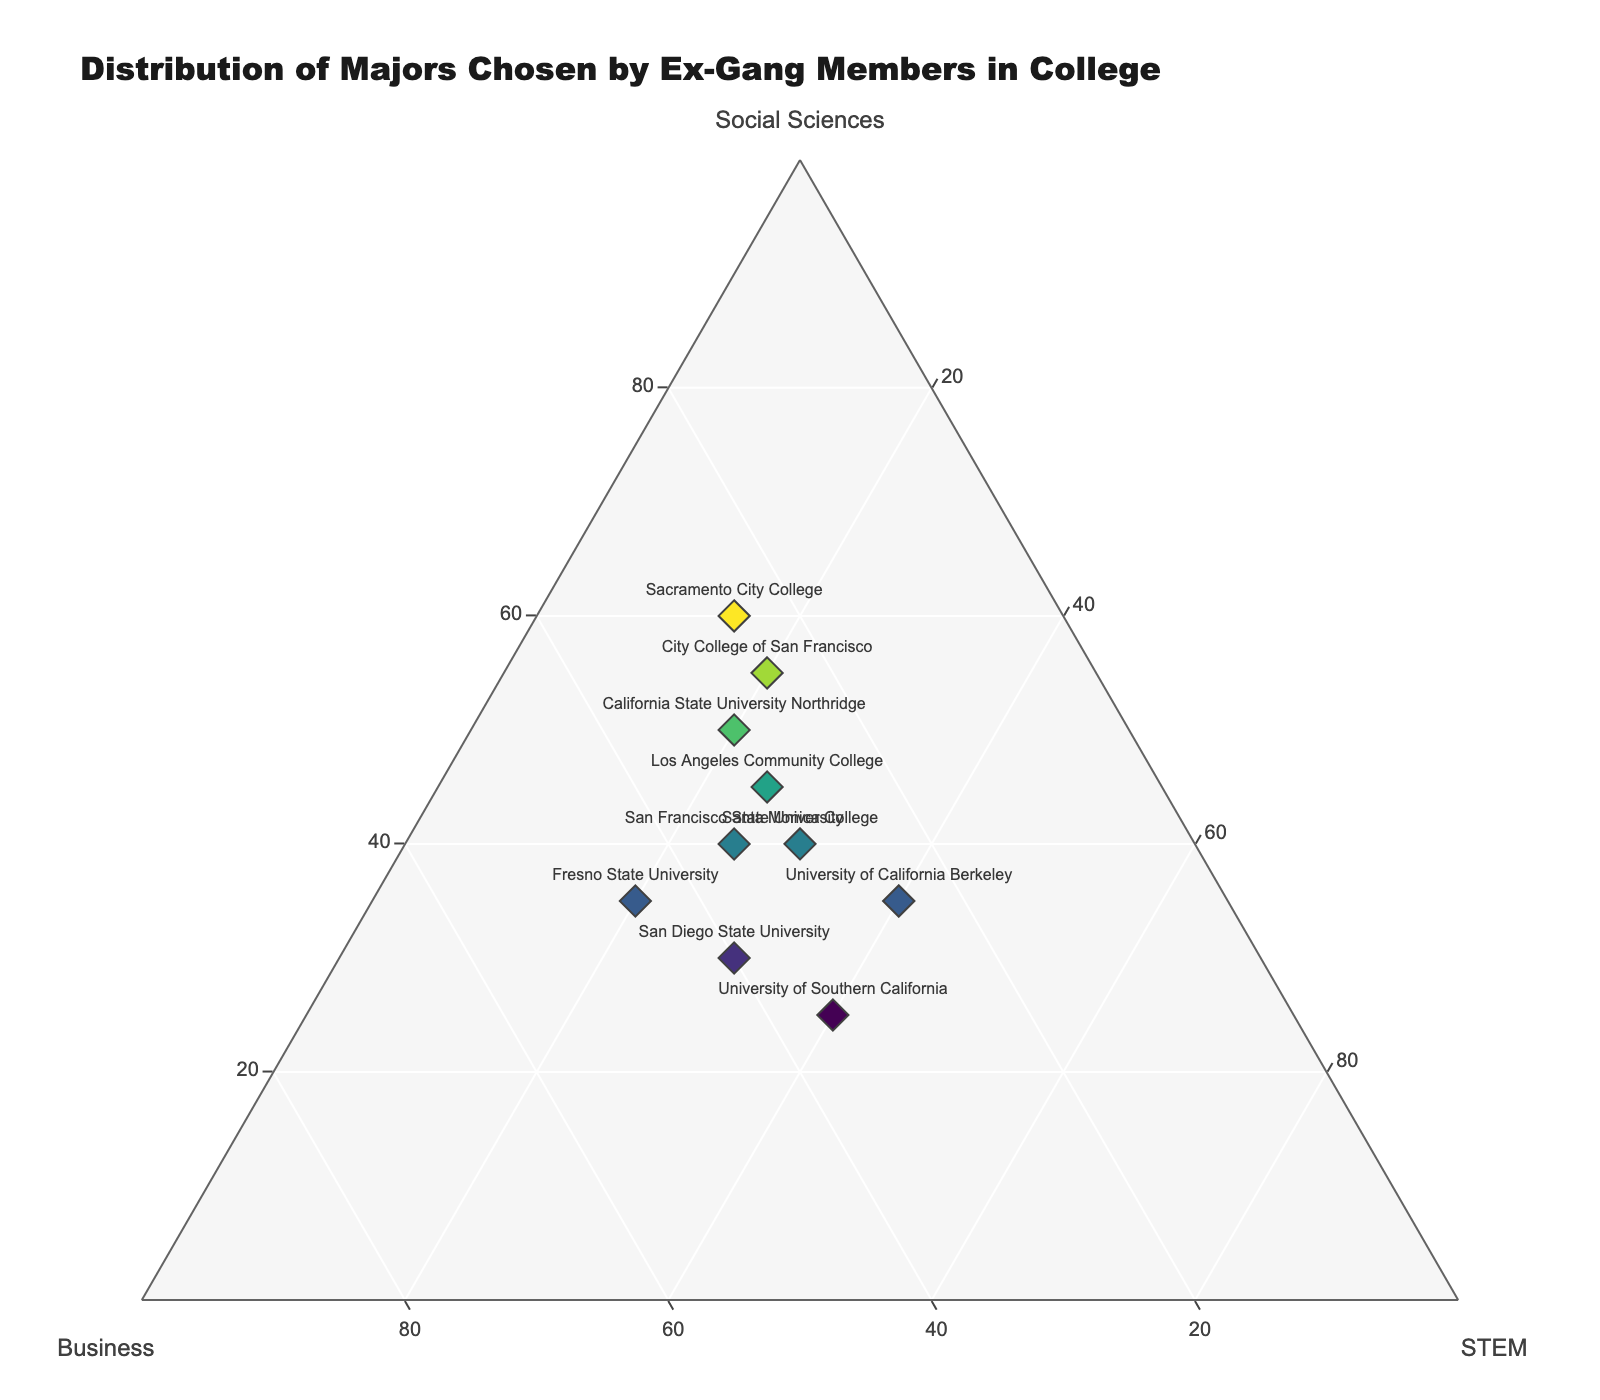What is the title of the plot? The title is usually displayed at the top of the figure. In this case, the title of the plot provides a summary of what the figure represents.
Answer: Distribution of Majors Chosen by Ex-Gang Members in College How many educational institutions are represented in the plot? Count the number of unique data points or markers, each representing an educational institution.
Answer: 10 Which institution has the highest percentage of students in Social Sciences? Look for the marker placed furthest along the 'Social Sciences' axis. The text label next to this marker will indicate the institution.
Answer: Sacramento City College (60%) Which institution has an equal distribution of majors between Social Sciences, Business, and STEM? Look for a marker placed centrally where all three categories have roughly equal proportions.
Answer: Santa Monica College (40%, 30%, 30%) Which institutions have higher percentages in Business compared to STEM? Compare the 'Business' and 'STEM' values for all institutions and select those where the 'Business' value is greater.
Answer: San Diego State University, Fresno State University What’s the average percentage of students in STEM fields across all institutions? Add all 'STEM' percentages together and divide by the number of institutions (10). (25 + 25 + 40 + 20 + 20 + 30 + 40 + 15 + 20 + 30) / 10
Answer: 26% Which institution has the closest percentage distribution between Business and Social Sciences? Calculate the difference between 'Business' and 'Social Sciences' for each institution and find the smallest difference.
Answer: Fresno State University (10% difference) Across all institutions, what is the median percentage of students majoring in Business? List all 'Business' percentages in ascending order and find the middle value. If there are an even number of observations, take the average of the two middle values. (25, 25, 25, 30, 30, 30, 35, 35, 40, 45) Median of 30 and 30
Answer: 30% For which institution is the marker color the darkest? Marker color intensity varies with the 'Social Sciences' percentage. The institution with the highest percentage in 'Social Sciences' will have the darkest marker.
Answer: Sacramento City College Which institutions fall into a category with less than 20% STEM majors? Identify markers near the edge of the 'STEM' axis with values less than 20%.
Answer: California State University Northridge, City College of San Francisco, Sacramento City College, Fresno State University 